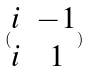<formula> <loc_0><loc_0><loc_500><loc_500>( \begin{matrix} i & - 1 \\ i & 1 \end{matrix} )</formula> 